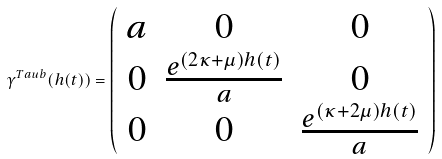Convert formula to latex. <formula><loc_0><loc_0><loc_500><loc_500>\gamma ^ { T a u b } ( h ( t ) ) = \left ( \begin{array} { c c c } a & 0 & 0 \\ 0 & \frac { e ^ { ( 2 \kappa + \mu ) h ( t ) } } { a } & 0 \\ 0 & 0 & \frac { e ^ { ( \kappa + 2 \mu ) h ( t ) } } { a } \end{array} \right )</formula> 